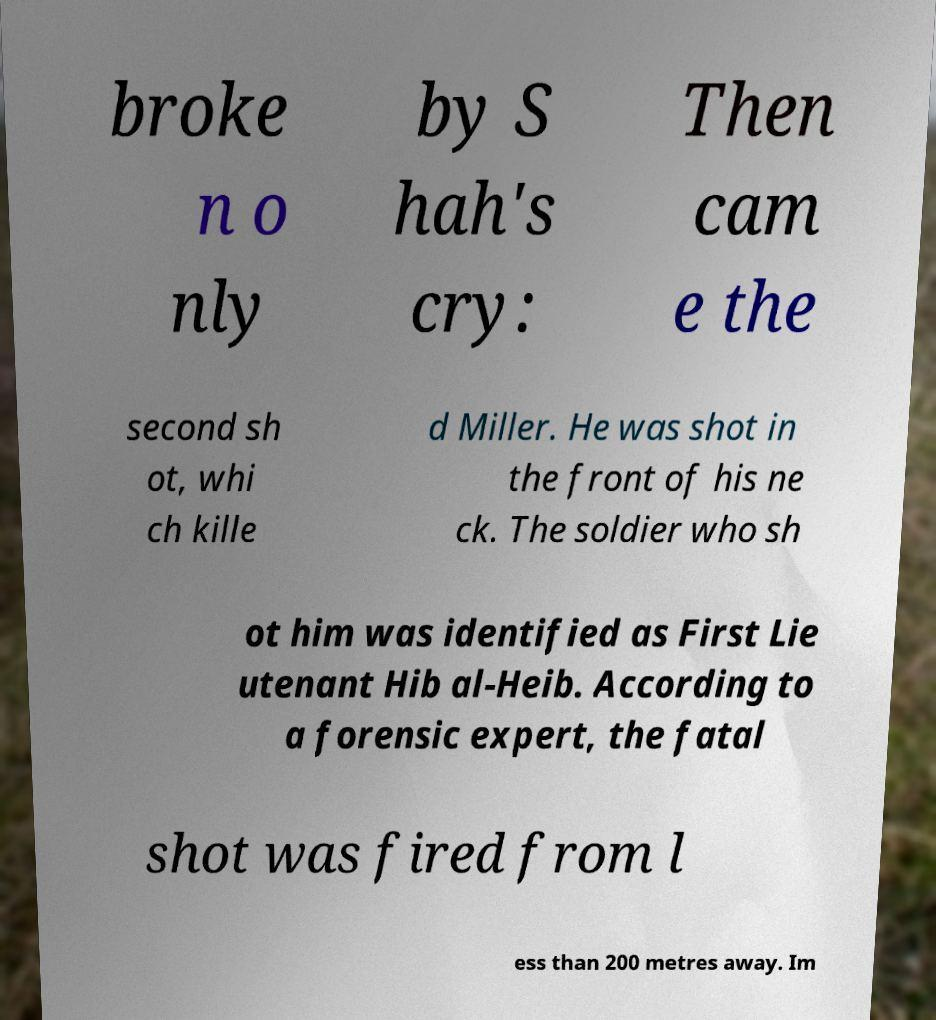Could you assist in decoding the text presented in this image and type it out clearly? broke n o nly by S hah's cry: Then cam e the second sh ot, whi ch kille d Miller. He was shot in the front of his ne ck. The soldier who sh ot him was identified as First Lie utenant Hib al-Heib. According to a forensic expert, the fatal shot was fired from l ess than 200 metres away. Im 